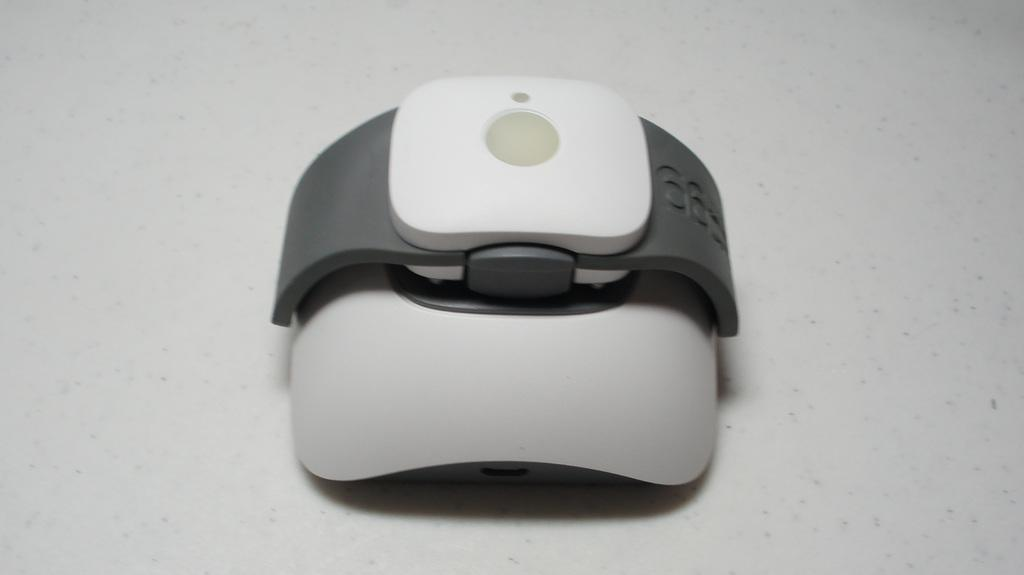What type of object is the main focus of the image? There is an electronic gadget in the image. What type of glove is being used to operate the electronic gadget in the image? There is no glove or operation of the electronic gadget depicted in the image. 